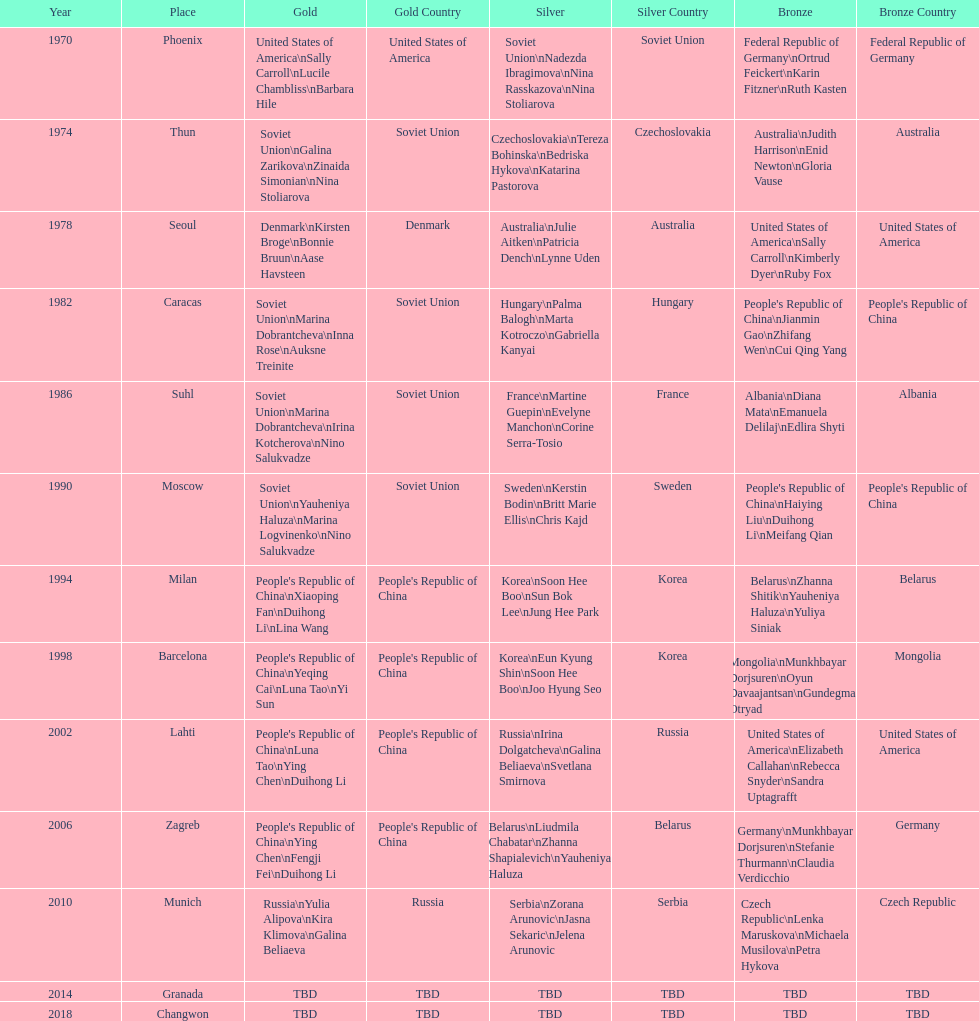What is the number of total bronze medals that germany has won? 1. 